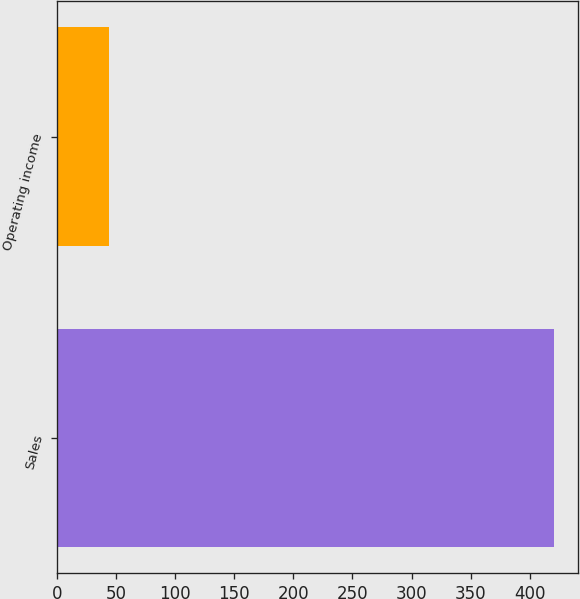Convert chart to OTSL. <chart><loc_0><loc_0><loc_500><loc_500><bar_chart><fcel>Sales<fcel>Operating income<nl><fcel>420.1<fcel>44.6<nl></chart> 